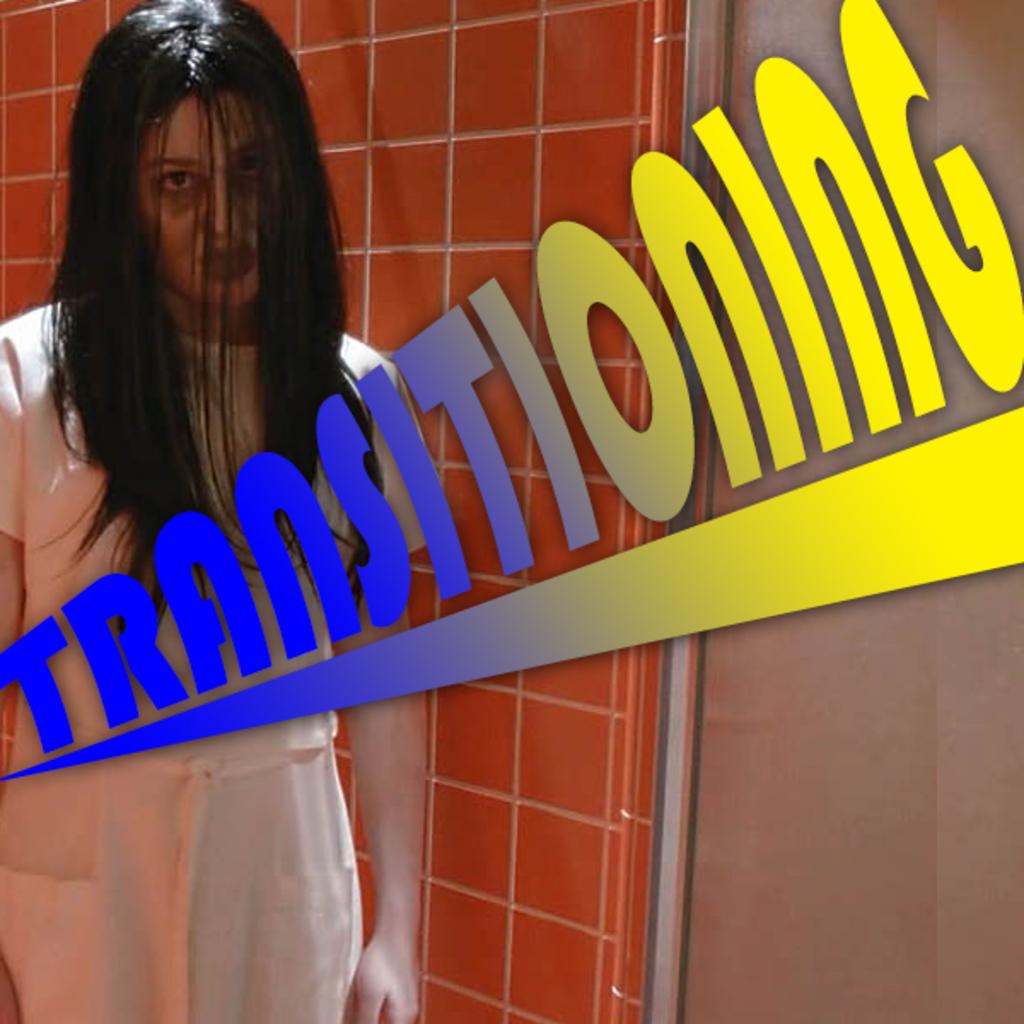What is this image about?
Provide a succinct answer. Transitioning. 